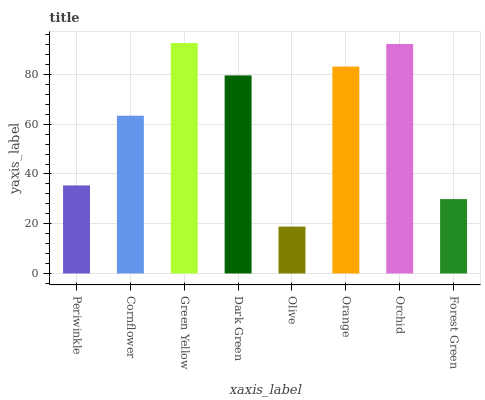Is Cornflower the minimum?
Answer yes or no. No. Is Cornflower the maximum?
Answer yes or no. No. Is Cornflower greater than Periwinkle?
Answer yes or no. Yes. Is Periwinkle less than Cornflower?
Answer yes or no. Yes. Is Periwinkle greater than Cornflower?
Answer yes or no. No. Is Cornflower less than Periwinkle?
Answer yes or no. No. Is Dark Green the high median?
Answer yes or no. Yes. Is Cornflower the low median?
Answer yes or no. Yes. Is Orange the high median?
Answer yes or no. No. Is Green Yellow the low median?
Answer yes or no. No. 